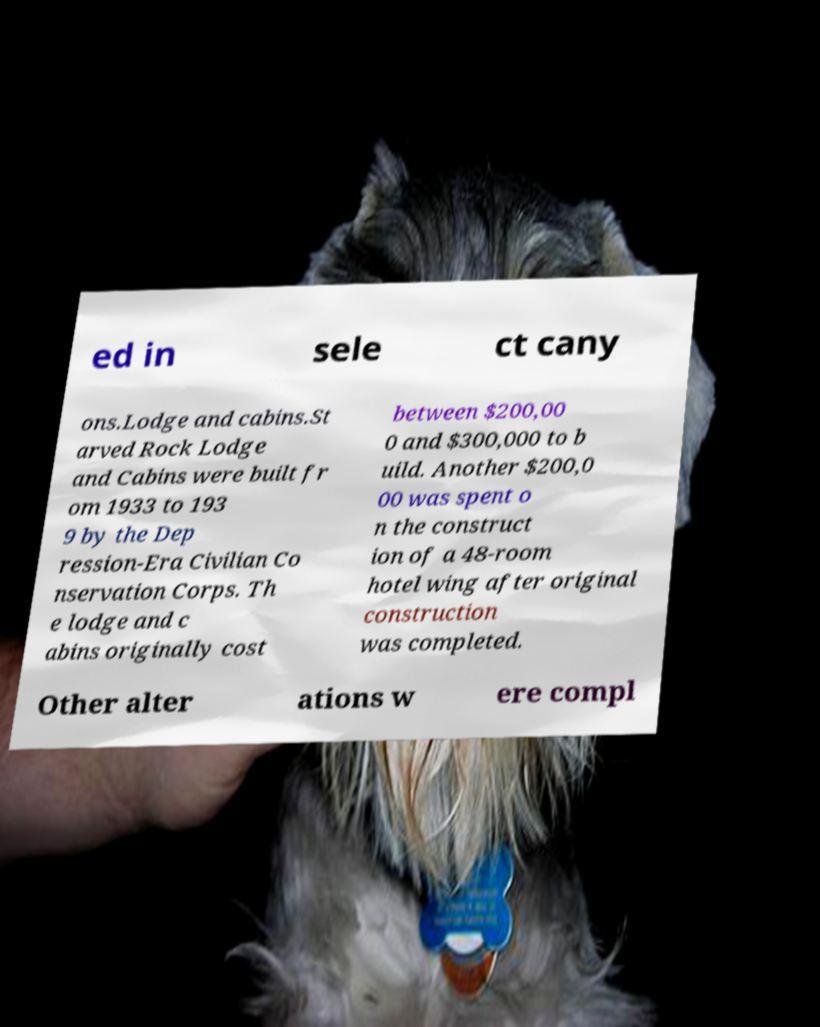Please identify and transcribe the text found in this image. ed in sele ct cany ons.Lodge and cabins.St arved Rock Lodge and Cabins were built fr om 1933 to 193 9 by the Dep ression-Era Civilian Co nservation Corps. Th e lodge and c abins originally cost between $200,00 0 and $300,000 to b uild. Another $200,0 00 was spent o n the construct ion of a 48-room hotel wing after original construction was completed. Other alter ations w ere compl 